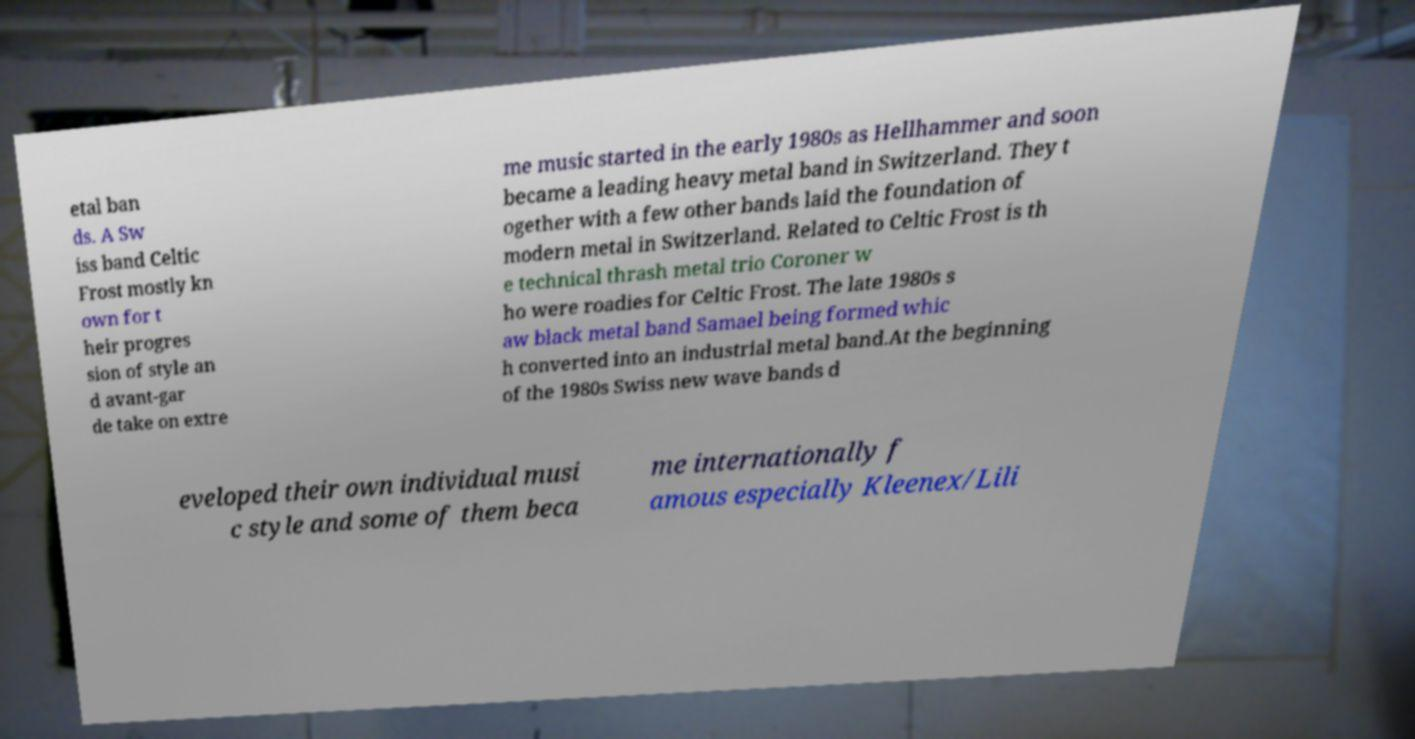Could you extract and type out the text from this image? etal ban ds. A Sw iss band Celtic Frost mostly kn own for t heir progres sion of style an d avant-gar de take on extre me music started in the early 1980s as Hellhammer and soon became a leading heavy metal band in Switzerland. They t ogether with a few other bands laid the foundation of modern metal in Switzerland. Related to Celtic Frost is th e technical thrash metal trio Coroner w ho were roadies for Celtic Frost. The late 1980s s aw black metal band Samael being formed whic h converted into an industrial metal band.At the beginning of the 1980s Swiss new wave bands d eveloped their own individual musi c style and some of them beca me internationally f amous especially Kleenex/Lili 